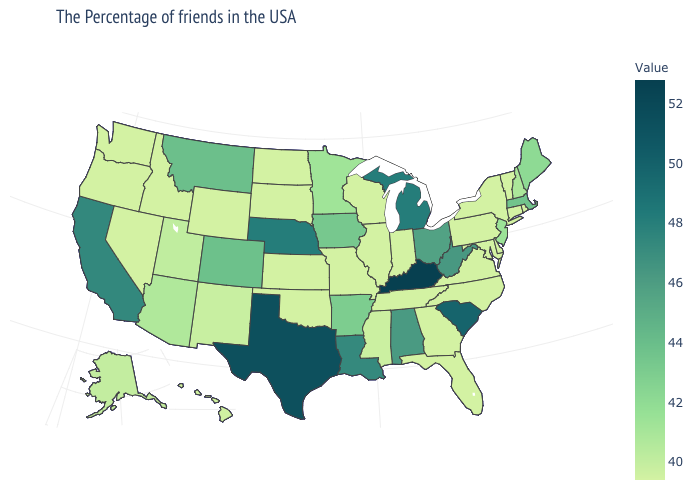Does the map have missing data?
Give a very brief answer. No. Does Indiana have the lowest value in the USA?
Quick response, please. Yes. Which states have the lowest value in the Northeast?
Keep it brief. Rhode Island, Vermont, Connecticut, New York, Pennsylvania. Which states have the lowest value in the USA?
Quick response, please. Rhode Island, Vermont, Connecticut, New York, Delaware, Maryland, Pennsylvania, Virginia, North Carolina, Florida, Georgia, Indiana, Tennessee, Wisconsin, Illinois, Missouri, Kansas, Oklahoma, South Dakota, North Dakota, Wyoming, Idaho, Nevada, Washington, Oregon. 